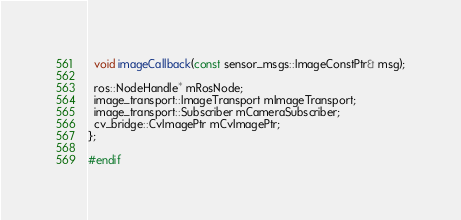<code> <loc_0><loc_0><loc_500><loc_500><_C_>  void imageCallback(const sensor_msgs::ImageConstPtr& msg);

  ros::NodeHandle* mRosNode;
  image_transport::ImageTransport mImageTransport;
  image_transport::Subscriber mCameraSubscriber;
  cv_bridge::CvImagePtr mCvImagePtr;
};

#endif
</code> 